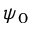<formula> <loc_0><loc_0><loc_500><loc_500>\psi _ { 0 }</formula> 